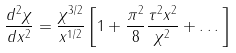<formula> <loc_0><loc_0><loc_500><loc_500>\frac { d ^ { 2 } \chi } { d x ^ { 2 } } = \frac { \chi ^ { 3 / 2 } } { x ^ { 1 / 2 } } \left [ 1 + \frac { \pi ^ { 2 } } { 8 } \frac { \tau ^ { 2 } x ^ { 2 } } { \chi ^ { 2 } } + \dots \right ]</formula> 